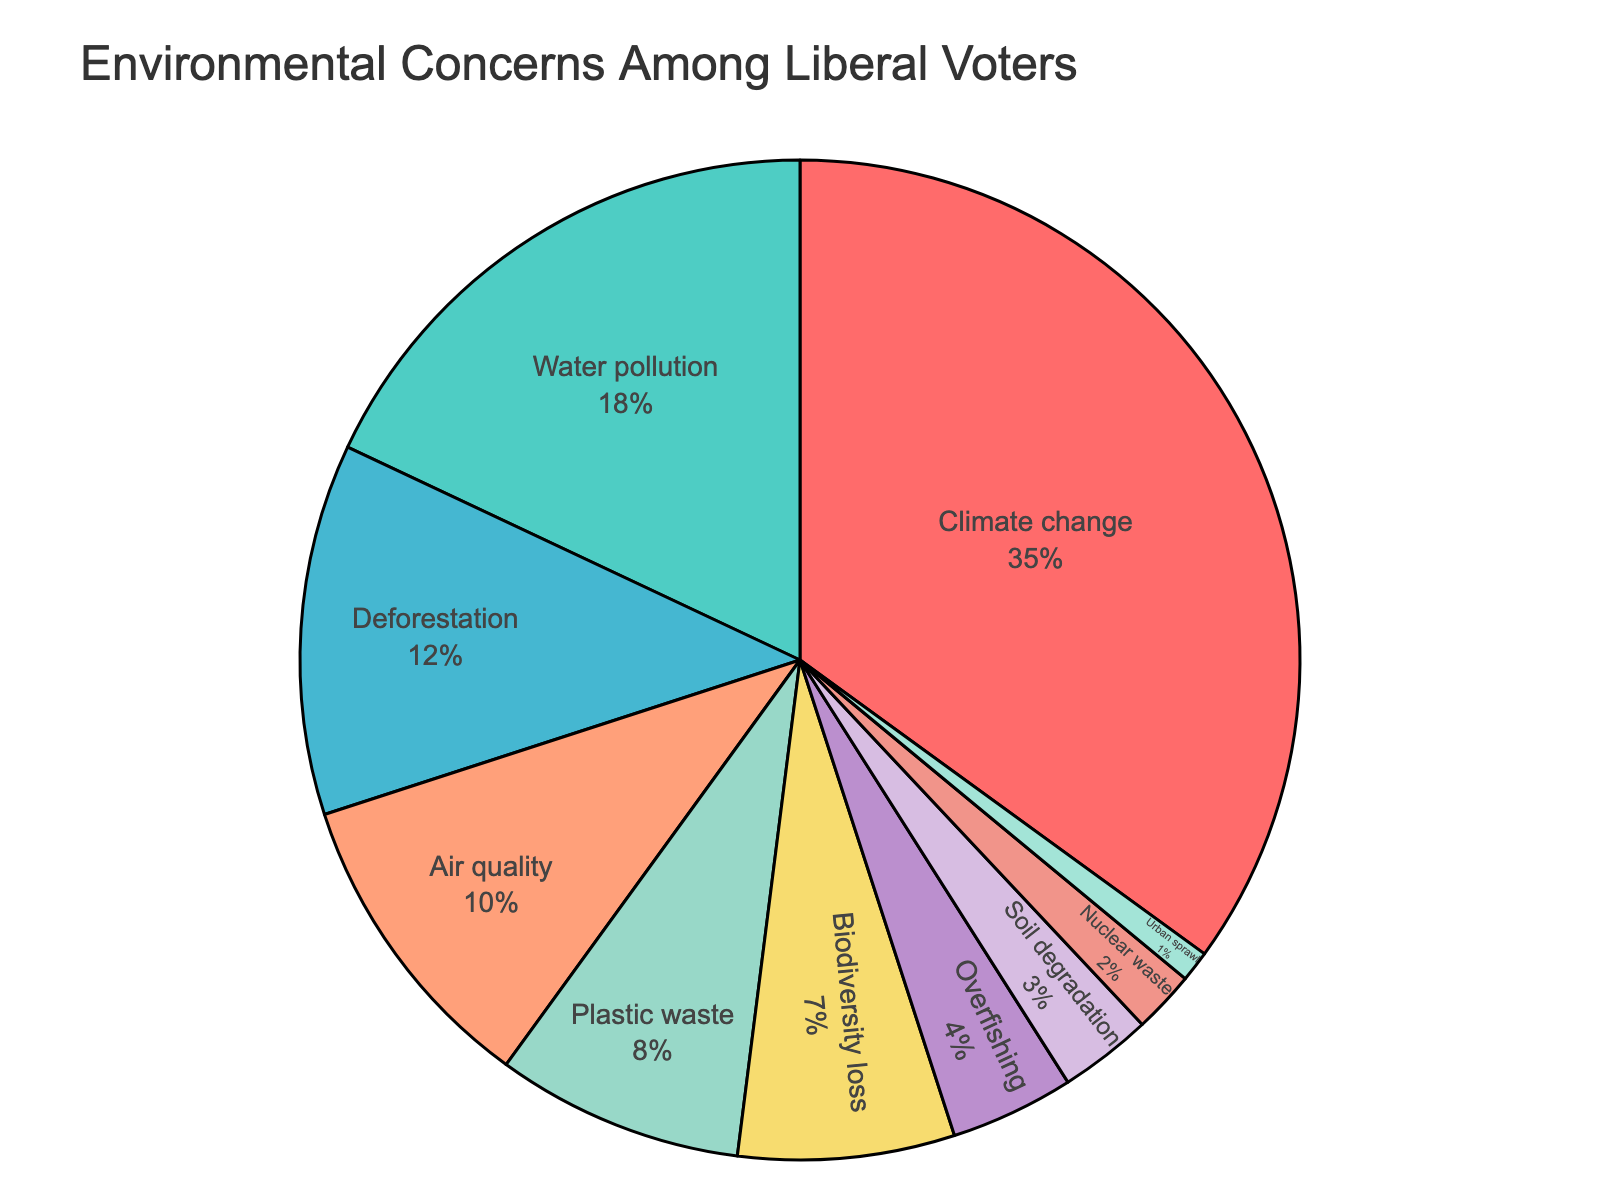What's the largest environmental concern among liberal voters? The largest slice in the pie chart is labeled "Climate change," which occupies 35% of the total, making it the most significant concern.
Answer: Climate change What percentage of concerns are related to water pollution and plastic waste combined? Add the percentages for Water pollution (18%) and Plastic waste (8%). 18 + 8 = 26
Answer: 26% Is air quality a bigger concern than biodiversity loss? The pie chart shows Air quality at 10% and Biodiversity loss at 7%. Therefore, Air quality is a bigger concern.
Answer: Yes Which concerns make up more than 15% of the total? In the pie chart, Climate change (35%) and Water pollution (18%) are both above 15%.
Answer: Climate change and Water pollution What is the combined percentage for concerns related to deforestation, nuclear waste, and urban sprawl? Add the percentages for Deforestation (12%), Nuclear waste (2%), and Urban sprawl (1%). 12 + 2 + 1 = 15
Answer: 15% Which category has the smallest portion, and what is its percentage? Urban sprawl has the smallest portion in the pie chart with 1%.
Answer: Urban sprawl, 1% Compare the concerns for climate change and overfishing. What is the numerical difference in their percentages? Climate change is 35% and Overfishing is 4%. The difference is 35 - 4 = 31
Answer: 31 Which categories make up less than 5% each? Overfishing (4%), Soil degradation (3%), Nuclear waste (2%), and Urban sprawl (1%) each make up less than 5%.
Answer: Overfishing, Soil degradation, Nuclear waste, Urban sprawl How do the concerns of air quality and plastic waste compare in terms of percentage? Air quality is 10% and Plastic waste is 8%. Air quality percentage is greater than Plastic waste.
Answer: Air quality is greater What is the total percentage for the categories not related to pollution (Water pollution, Air quality, and Plastic waste)? Exclude Water pollution (18%), Air quality (10%), and Plastic waste (8%) and sum the remaining categories: 35 + 12 + 7 + 4 + 3 + 2 + 1 = 64
Answer: 64% 